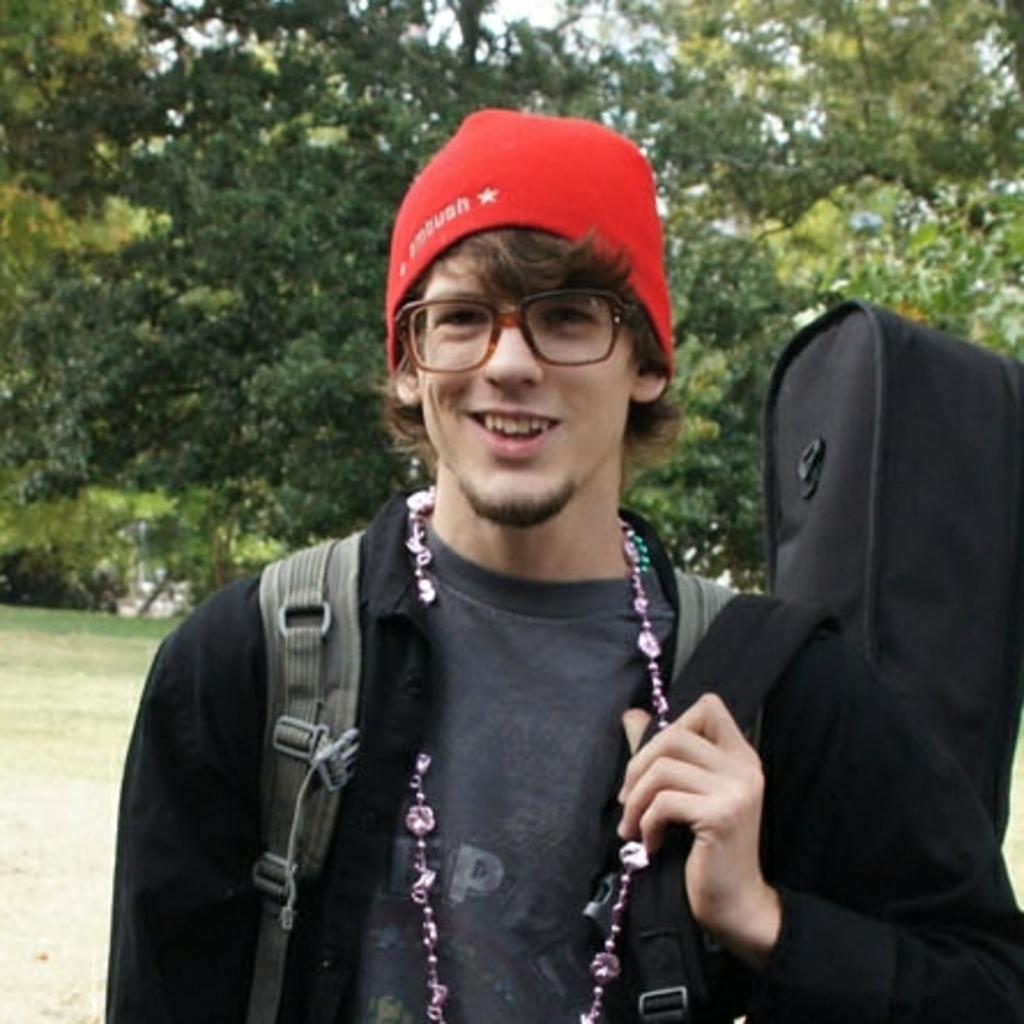In one or two sentences, can you explain what this image depicts? In the picture we can see a man standing and holding some bag and wearing some back bag and with a red cap and he is smiling and in the background we can see a grass surface and trees. 